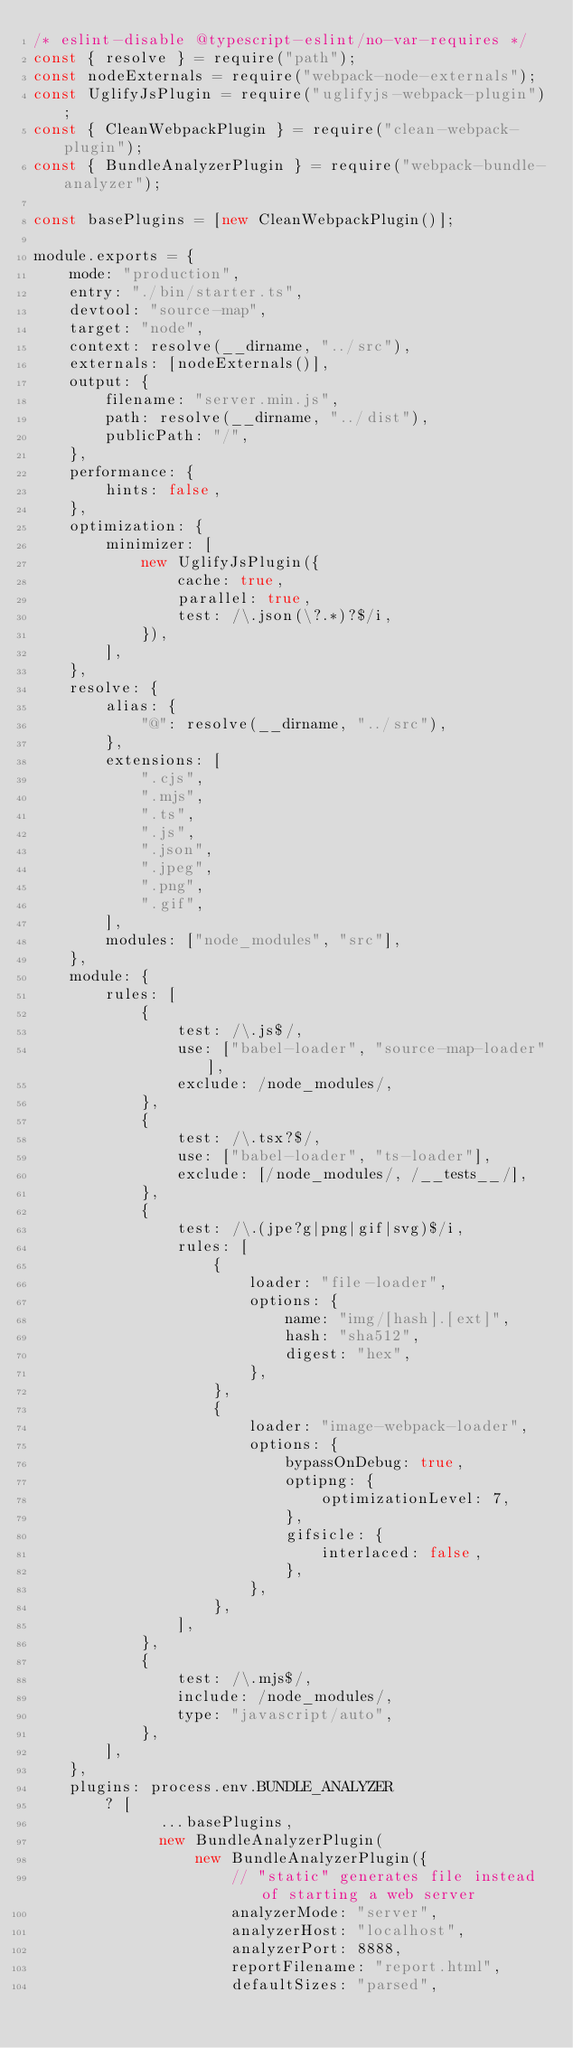Convert code to text. <code><loc_0><loc_0><loc_500><loc_500><_JavaScript_>/* eslint-disable @typescript-eslint/no-var-requires */
const { resolve } = require("path");
const nodeExternals = require("webpack-node-externals");
const UglifyJsPlugin = require("uglifyjs-webpack-plugin");
const { CleanWebpackPlugin } = require("clean-webpack-plugin");
const { BundleAnalyzerPlugin } = require("webpack-bundle-analyzer");

const basePlugins = [new CleanWebpackPlugin()];

module.exports = {
    mode: "production",
    entry: "./bin/starter.ts",
    devtool: "source-map",
    target: "node",
    context: resolve(__dirname, "../src"),
    externals: [nodeExternals()],
    output: {
        filename: "server.min.js",
        path: resolve(__dirname, "../dist"),
        publicPath: "/",
    },
    performance: {
        hints: false,
    },
    optimization: {
        minimizer: [
            new UglifyJsPlugin({
                cache: true,
                parallel: true,
                test: /\.json(\?.*)?$/i,
            }),
        ],
    },
    resolve: {
        alias: {
            "@": resolve(__dirname, "../src"),
        },
        extensions: [
            ".cjs",
            ".mjs",
            ".ts",
            ".js",
            ".json",
            ".jpeg",
            ".png",
            ".gif",
        ],
        modules: ["node_modules", "src"],
    },
    module: {
        rules: [
            {
                test: /\.js$/,
                use: ["babel-loader", "source-map-loader"],
                exclude: /node_modules/,
            },
            {
                test: /\.tsx?$/,
                use: ["babel-loader", "ts-loader"],
                exclude: [/node_modules/, /__tests__/],
            },
            {
                test: /\.(jpe?g|png|gif|svg)$/i,
                rules: [
                    {
                        loader: "file-loader",
                        options: {
                            name: "img/[hash].[ext]",
                            hash: "sha512",
                            digest: "hex",
                        },
                    },
                    {
                        loader: "image-webpack-loader",
                        options: {
                            bypassOnDebug: true,
                            optipng: {
                                optimizationLevel: 7,
                            },
                            gifsicle: {
                                interlaced: false,
                            },
                        },
                    },
                ],
            },
            {
                test: /\.mjs$/,
                include: /node_modules/,
                type: "javascript/auto",
            },
        ],
    },
    plugins: process.env.BUNDLE_ANALYZER
        ? [
              ...basePlugins,
              new BundleAnalyzerPlugin(
                  new BundleAnalyzerPlugin({
                      // "static" generates file instead of starting a web server
                      analyzerMode: "server",
                      analyzerHost: "localhost",
                      analyzerPort: 8888,
                      reportFilename: "report.html",
                      defaultSizes: "parsed",</code> 